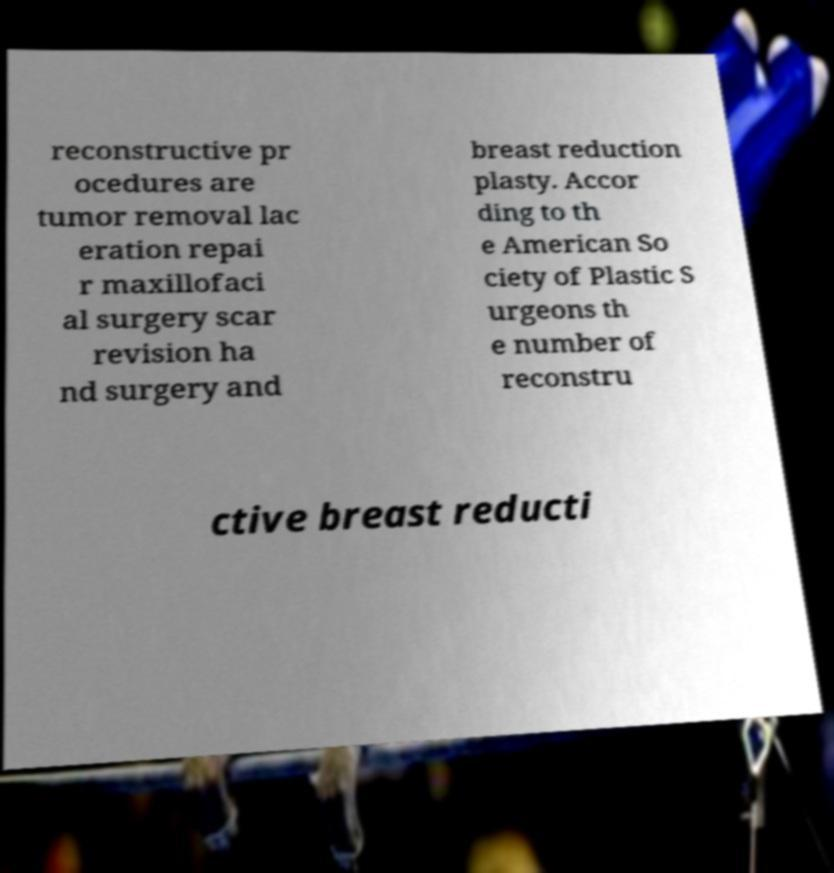Can you accurately transcribe the text from the provided image for me? reconstructive pr ocedures are tumor removal lac eration repai r maxillofaci al surgery scar revision ha nd surgery and breast reduction plasty. Accor ding to th e American So ciety of Plastic S urgeons th e number of reconstru ctive breast reducti 